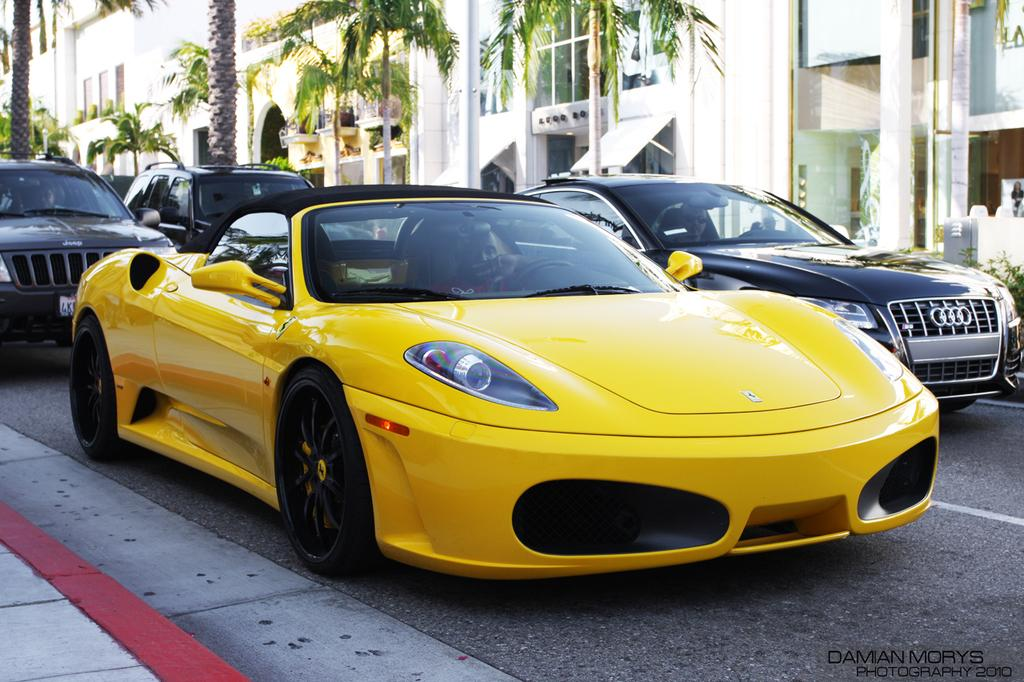What can be seen in the middle of the image? There are vehicles on the road in the center of the image. What is visible in the background of the image? There are buildings, trees, and a fountain in the background of the image. What type of twig can be seen growing from the fountain in the image? There is no twig visible in the image, and the fountain is not described as having any plant life growing from it. 